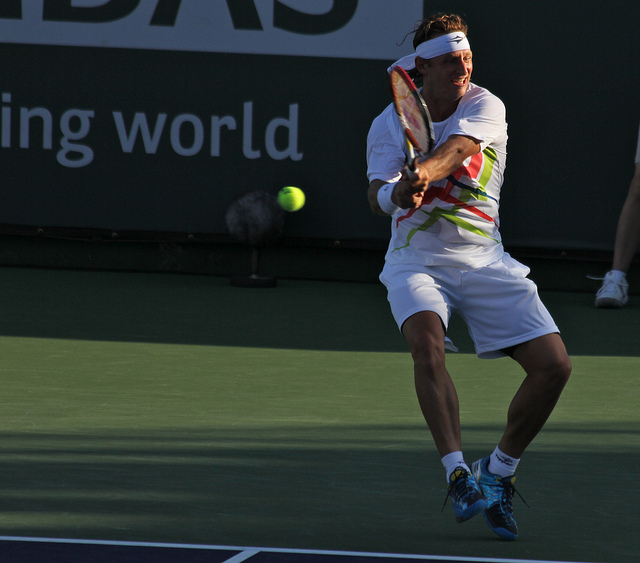<image>What court number is the man playing on? I am not sure about the court number the man is playing on. It could be court 1 or court 3. What court number is the man playing on? I don't know what court number the man is playing on. It can be either 1 or 3. 